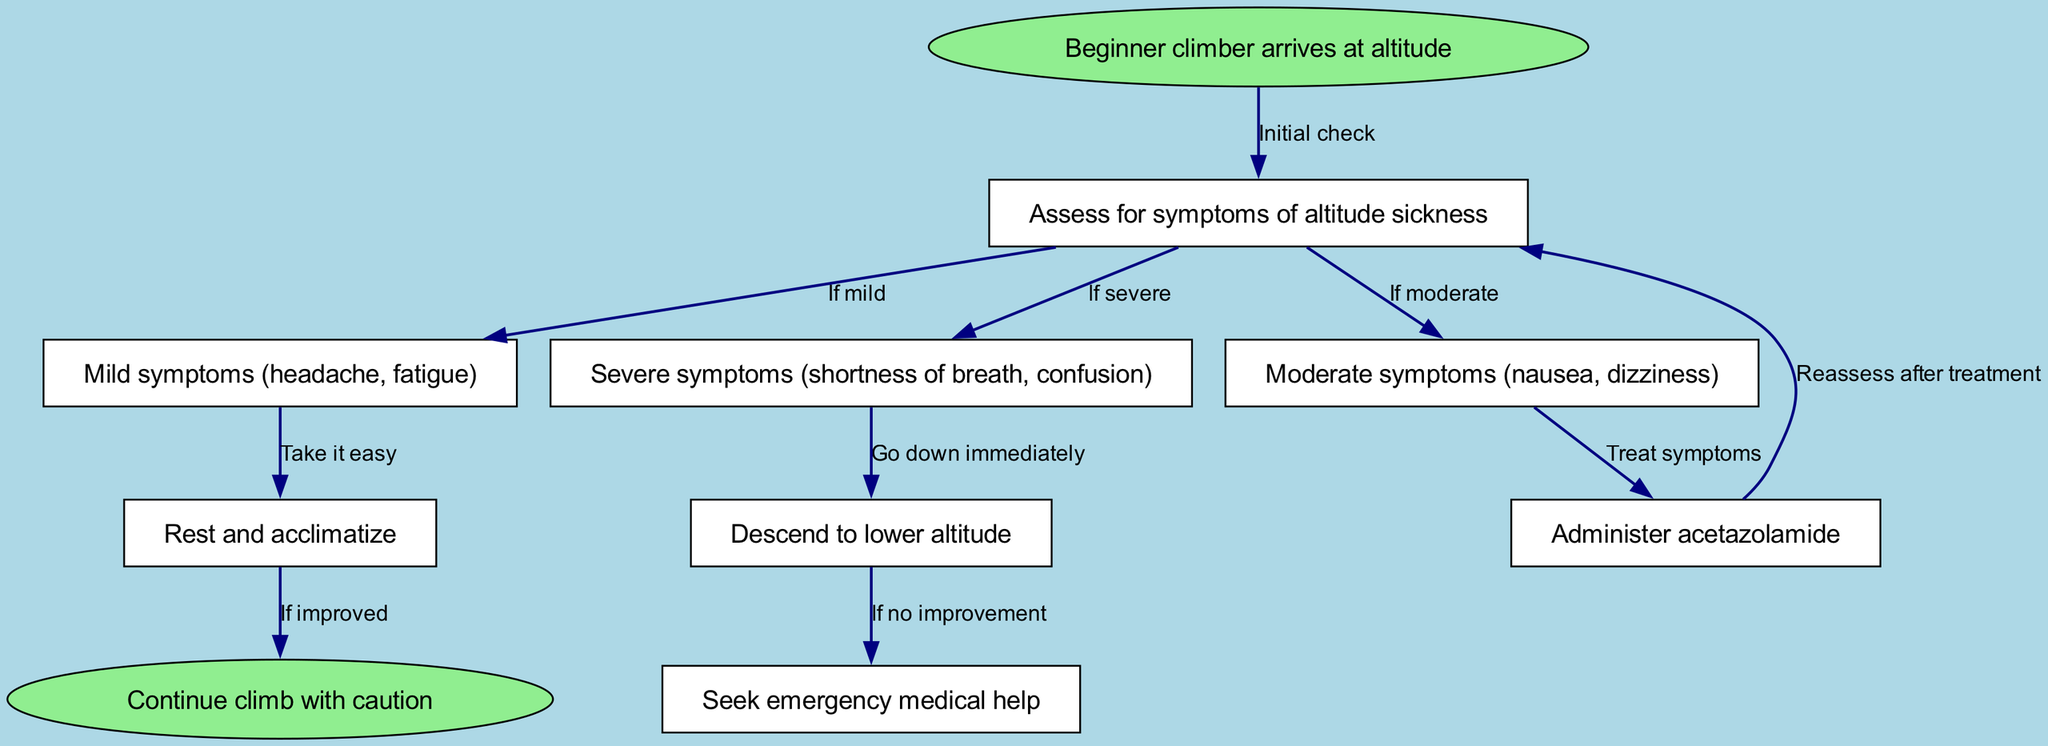What is the starting condition in the diagram? The starting condition is represented by the node labeled "Beginner climber arrives at altitude." This node is the initial point in the clinical pathway and does not follow any edges, indicating where the assessment begins.
Answer: Beginner climber arrives at altitude How many total nodes are in the diagram? By counting the unique nodes listed in the diagram, we can determine that there are 9 nodes, including both starting and ending points. This count includes all the stages of assessing and managing altitude sickness.
Answer: 9 What happens if a climber shows severe symptoms? According to the diagram, if a climber shows severe symptoms (noted in the corresponding node), the recommended action is to "Descend to lower altitude," indicating immediate action is necessary for safety.
Answer: Descend to lower altitude What is the next step after treating moderate symptoms? Once moderate symptoms are addressed with medication (the relevant node), the diagram directs us back to "Assess for symptoms of altitude sickness," highlighting the need for reassessment after treatment is administered.
Answer: Assess for symptoms of altitude sickness How many edges are connected to the "Assess for symptoms of altitude sickness" node? The "Assess for symptoms of altitude sickness" node connects to three different nodes: "Mild symptoms," "Moderate symptoms," and "Severe symptoms." These connections illustrate the different pathways depending on the symptom severity assessed.
Answer: 3 What should a climber do if their condition does not improve after descending? The next step, if there is no improvement after descending, is to "Seek emergency medical help," as indicated in the diagram, emphasizing the need for immediate medical attention.
Answer: Seek emergency medical help What is the outcome if the climber improves after resting? If the climber feels better after the resting period, the diagram indicates that they should "Continue climb with caution," allowing for a safe resumption of their climbing activities with awareness of previous symptoms.
Answer: Continue climb with caution What does the "Mild symptoms" node recommend? The diagram suggests that for mild symptoms (such as headache or fatigue), the action is to "Rest and acclimatize," which aligns with recommended practices for handling mild forms of altitude sickness.
Answer: Rest and acclimatize 